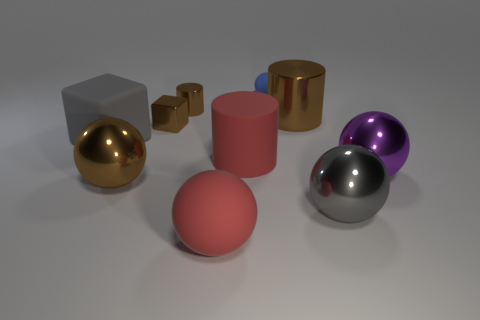What number of brown objects have the same size as the brown ball?
Your response must be concise. 1. What is the shape of the purple object in front of the brown metal cylinder left of the big red rubber cylinder?
Ensure brevity in your answer.  Sphere. Is the number of large cyan matte balls less than the number of brown things?
Offer a very short reply. Yes. The small ball behind the red rubber ball is what color?
Keep it short and to the point. Blue. There is a object that is both to the left of the small block and in front of the matte cube; what material is it made of?
Give a very brief answer. Metal. The large gray thing that is the same material as the brown ball is what shape?
Offer a very short reply. Sphere. What number of brown metallic spheres are behind the block on the right side of the large gray matte thing?
Your answer should be compact. 0. What number of metallic cylinders are both left of the blue object and on the right side of the red rubber sphere?
Make the answer very short. 0. What number of other objects are the same material as the red ball?
Provide a succinct answer. 3. The tiny metal object in front of the big brown shiny object that is behind the big cube is what color?
Keep it short and to the point. Brown. 